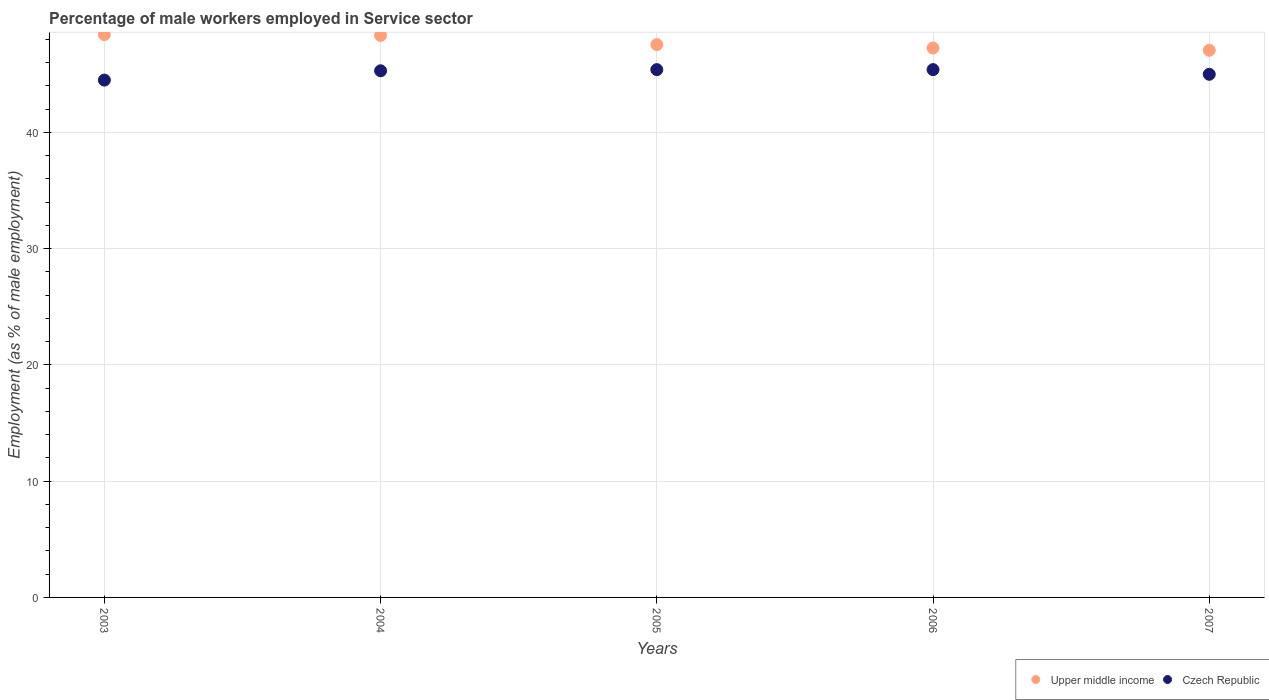How many different coloured dotlines are there?
Give a very brief answer. 2. What is the percentage of male workers employed in Service sector in Upper middle income in 2007?
Provide a succinct answer. 47.06. Across all years, what is the maximum percentage of male workers employed in Service sector in Upper middle income?
Keep it short and to the point. 48.42. Across all years, what is the minimum percentage of male workers employed in Service sector in Czech Republic?
Keep it short and to the point. 44.5. What is the total percentage of male workers employed in Service sector in Upper middle income in the graph?
Make the answer very short. 238.64. What is the difference between the percentage of male workers employed in Service sector in Czech Republic in 2004 and that in 2006?
Ensure brevity in your answer.  -0.1. What is the difference between the percentage of male workers employed in Service sector in Upper middle income in 2006 and the percentage of male workers employed in Service sector in Czech Republic in 2005?
Keep it short and to the point. 1.86. What is the average percentage of male workers employed in Service sector in Upper middle income per year?
Your response must be concise. 47.73. In the year 2004, what is the difference between the percentage of male workers employed in Service sector in Upper middle income and percentage of male workers employed in Service sector in Czech Republic?
Keep it short and to the point. 3.05. In how many years, is the percentage of male workers employed in Service sector in Czech Republic greater than 12 %?
Make the answer very short. 5. What is the ratio of the percentage of male workers employed in Service sector in Czech Republic in 2004 to that in 2005?
Keep it short and to the point. 1. Is the percentage of male workers employed in Service sector in Upper middle income in 2005 less than that in 2006?
Provide a short and direct response. No. Is the difference between the percentage of male workers employed in Service sector in Upper middle income in 2005 and 2006 greater than the difference between the percentage of male workers employed in Service sector in Czech Republic in 2005 and 2006?
Provide a short and direct response. Yes. What is the difference between the highest and the second highest percentage of male workers employed in Service sector in Upper middle income?
Your answer should be very brief. 0.07. What is the difference between the highest and the lowest percentage of male workers employed in Service sector in Upper middle income?
Ensure brevity in your answer.  1.35. In how many years, is the percentage of male workers employed in Service sector in Czech Republic greater than the average percentage of male workers employed in Service sector in Czech Republic taken over all years?
Your answer should be very brief. 3. Is the sum of the percentage of male workers employed in Service sector in Upper middle income in 2004 and 2005 greater than the maximum percentage of male workers employed in Service sector in Czech Republic across all years?
Your response must be concise. Yes. Does the percentage of male workers employed in Service sector in Czech Republic monotonically increase over the years?
Give a very brief answer. No. How many years are there in the graph?
Your answer should be very brief. 5. Does the graph contain grids?
Ensure brevity in your answer.  Yes. What is the title of the graph?
Your answer should be compact. Percentage of male workers employed in Service sector. What is the label or title of the X-axis?
Keep it short and to the point. Years. What is the label or title of the Y-axis?
Make the answer very short. Employment (as % of male employment). What is the Employment (as % of male employment) of Upper middle income in 2003?
Make the answer very short. 48.42. What is the Employment (as % of male employment) of Czech Republic in 2003?
Ensure brevity in your answer.  44.5. What is the Employment (as % of male employment) in Upper middle income in 2004?
Your answer should be compact. 48.35. What is the Employment (as % of male employment) of Czech Republic in 2004?
Provide a short and direct response. 45.3. What is the Employment (as % of male employment) of Upper middle income in 2005?
Keep it short and to the point. 47.55. What is the Employment (as % of male employment) of Czech Republic in 2005?
Offer a terse response. 45.4. What is the Employment (as % of male employment) of Upper middle income in 2006?
Give a very brief answer. 47.26. What is the Employment (as % of male employment) of Czech Republic in 2006?
Provide a succinct answer. 45.4. What is the Employment (as % of male employment) of Upper middle income in 2007?
Your answer should be compact. 47.06. What is the Employment (as % of male employment) in Czech Republic in 2007?
Provide a short and direct response. 45. Across all years, what is the maximum Employment (as % of male employment) in Upper middle income?
Your response must be concise. 48.42. Across all years, what is the maximum Employment (as % of male employment) in Czech Republic?
Your answer should be very brief. 45.4. Across all years, what is the minimum Employment (as % of male employment) in Upper middle income?
Your answer should be very brief. 47.06. Across all years, what is the minimum Employment (as % of male employment) in Czech Republic?
Your answer should be compact. 44.5. What is the total Employment (as % of male employment) in Upper middle income in the graph?
Give a very brief answer. 238.64. What is the total Employment (as % of male employment) in Czech Republic in the graph?
Provide a short and direct response. 225.6. What is the difference between the Employment (as % of male employment) of Upper middle income in 2003 and that in 2004?
Provide a short and direct response. 0.07. What is the difference between the Employment (as % of male employment) of Upper middle income in 2003 and that in 2005?
Provide a short and direct response. 0.87. What is the difference between the Employment (as % of male employment) in Upper middle income in 2003 and that in 2006?
Provide a succinct answer. 1.16. What is the difference between the Employment (as % of male employment) in Czech Republic in 2003 and that in 2006?
Provide a short and direct response. -0.9. What is the difference between the Employment (as % of male employment) of Upper middle income in 2003 and that in 2007?
Your response must be concise. 1.35. What is the difference between the Employment (as % of male employment) in Upper middle income in 2004 and that in 2005?
Give a very brief answer. 0.79. What is the difference between the Employment (as % of male employment) of Czech Republic in 2004 and that in 2005?
Give a very brief answer. -0.1. What is the difference between the Employment (as % of male employment) in Upper middle income in 2004 and that in 2006?
Offer a very short reply. 1.09. What is the difference between the Employment (as % of male employment) of Upper middle income in 2004 and that in 2007?
Offer a terse response. 1.28. What is the difference between the Employment (as % of male employment) of Czech Republic in 2004 and that in 2007?
Provide a succinct answer. 0.3. What is the difference between the Employment (as % of male employment) in Upper middle income in 2005 and that in 2006?
Your answer should be compact. 0.3. What is the difference between the Employment (as % of male employment) in Czech Republic in 2005 and that in 2006?
Your response must be concise. 0. What is the difference between the Employment (as % of male employment) of Upper middle income in 2005 and that in 2007?
Give a very brief answer. 0.49. What is the difference between the Employment (as % of male employment) of Czech Republic in 2005 and that in 2007?
Provide a short and direct response. 0.4. What is the difference between the Employment (as % of male employment) in Upper middle income in 2006 and that in 2007?
Your answer should be compact. 0.19. What is the difference between the Employment (as % of male employment) of Upper middle income in 2003 and the Employment (as % of male employment) of Czech Republic in 2004?
Your response must be concise. 3.12. What is the difference between the Employment (as % of male employment) of Upper middle income in 2003 and the Employment (as % of male employment) of Czech Republic in 2005?
Make the answer very short. 3.02. What is the difference between the Employment (as % of male employment) of Upper middle income in 2003 and the Employment (as % of male employment) of Czech Republic in 2006?
Keep it short and to the point. 3.02. What is the difference between the Employment (as % of male employment) of Upper middle income in 2003 and the Employment (as % of male employment) of Czech Republic in 2007?
Give a very brief answer. 3.42. What is the difference between the Employment (as % of male employment) of Upper middle income in 2004 and the Employment (as % of male employment) of Czech Republic in 2005?
Offer a very short reply. 2.95. What is the difference between the Employment (as % of male employment) of Upper middle income in 2004 and the Employment (as % of male employment) of Czech Republic in 2006?
Ensure brevity in your answer.  2.95. What is the difference between the Employment (as % of male employment) in Upper middle income in 2004 and the Employment (as % of male employment) in Czech Republic in 2007?
Provide a succinct answer. 3.35. What is the difference between the Employment (as % of male employment) in Upper middle income in 2005 and the Employment (as % of male employment) in Czech Republic in 2006?
Your response must be concise. 2.15. What is the difference between the Employment (as % of male employment) in Upper middle income in 2005 and the Employment (as % of male employment) in Czech Republic in 2007?
Ensure brevity in your answer.  2.55. What is the difference between the Employment (as % of male employment) of Upper middle income in 2006 and the Employment (as % of male employment) of Czech Republic in 2007?
Give a very brief answer. 2.26. What is the average Employment (as % of male employment) of Upper middle income per year?
Your response must be concise. 47.73. What is the average Employment (as % of male employment) of Czech Republic per year?
Keep it short and to the point. 45.12. In the year 2003, what is the difference between the Employment (as % of male employment) in Upper middle income and Employment (as % of male employment) in Czech Republic?
Make the answer very short. 3.92. In the year 2004, what is the difference between the Employment (as % of male employment) in Upper middle income and Employment (as % of male employment) in Czech Republic?
Keep it short and to the point. 3.05. In the year 2005, what is the difference between the Employment (as % of male employment) of Upper middle income and Employment (as % of male employment) of Czech Republic?
Your answer should be compact. 2.15. In the year 2006, what is the difference between the Employment (as % of male employment) of Upper middle income and Employment (as % of male employment) of Czech Republic?
Your response must be concise. 1.86. In the year 2007, what is the difference between the Employment (as % of male employment) in Upper middle income and Employment (as % of male employment) in Czech Republic?
Your answer should be very brief. 2.06. What is the ratio of the Employment (as % of male employment) in Upper middle income in 2003 to that in 2004?
Give a very brief answer. 1. What is the ratio of the Employment (as % of male employment) in Czech Republic in 2003 to that in 2004?
Make the answer very short. 0.98. What is the ratio of the Employment (as % of male employment) in Upper middle income in 2003 to that in 2005?
Your response must be concise. 1.02. What is the ratio of the Employment (as % of male employment) of Czech Republic in 2003 to that in 2005?
Provide a succinct answer. 0.98. What is the ratio of the Employment (as % of male employment) of Upper middle income in 2003 to that in 2006?
Your answer should be very brief. 1.02. What is the ratio of the Employment (as % of male employment) of Czech Republic in 2003 to that in 2006?
Make the answer very short. 0.98. What is the ratio of the Employment (as % of male employment) in Upper middle income in 2003 to that in 2007?
Provide a succinct answer. 1.03. What is the ratio of the Employment (as % of male employment) in Czech Republic in 2003 to that in 2007?
Keep it short and to the point. 0.99. What is the ratio of the Employment (as % of male employment) in Upper middle income in 2004 to that in 2005?
Ensure brevity in your answer.  1.02. What is the ratio of the Employment (as % of male employment) of Upper middle income in 2004 to that in 2006?
Offer a terse response. 1.02. What is the ratio of the Employment (as % of male employment) of Czech Republic in 2004 to that in 2006?
Ensure brevity in your answer.  1. What is the ratio of the Employment (as % of male employment) in Upper middle income in 2004 to that in 2007?
Offer a terse response. 1.03. What is the ratio of the Employment (as % of male employment) of Czech Republic in 2004 to that in 2007?
Offer a very short reply. 1.01. What is the ratio of the Employment (as % of male employment) in Upper middle income in 2005 to that in 2007?
Give a very brief answer. 1.01. What is the ratio of the Employment (as % of male employment) in Czech Republic in 2005 to that in 2007?
Offer a very short reply. 1.01. What is the ratio of the Employment (as % of male employment) in Upper middle income in 2006 to that in 2007?
Offer a very short reply. 1. What is the ratio of the Employment (as % of male employment) in Czech Republic in 2006 to that in 2007?
Keep it short and to the point. 1.01. What is the difference between the highest and the second highest Employment (as % of male employment) of Upper middle income?
Offer a terse response. 0.07. What is the difference between the highest and the second highest Employment (as % of male employment) of Czech Republic?
Your answer should be compact. 0. What is the difference between the highest and the lowest Employment (as % of male employment) in Upper middle income?
Your answer should be compact. 1.35. 